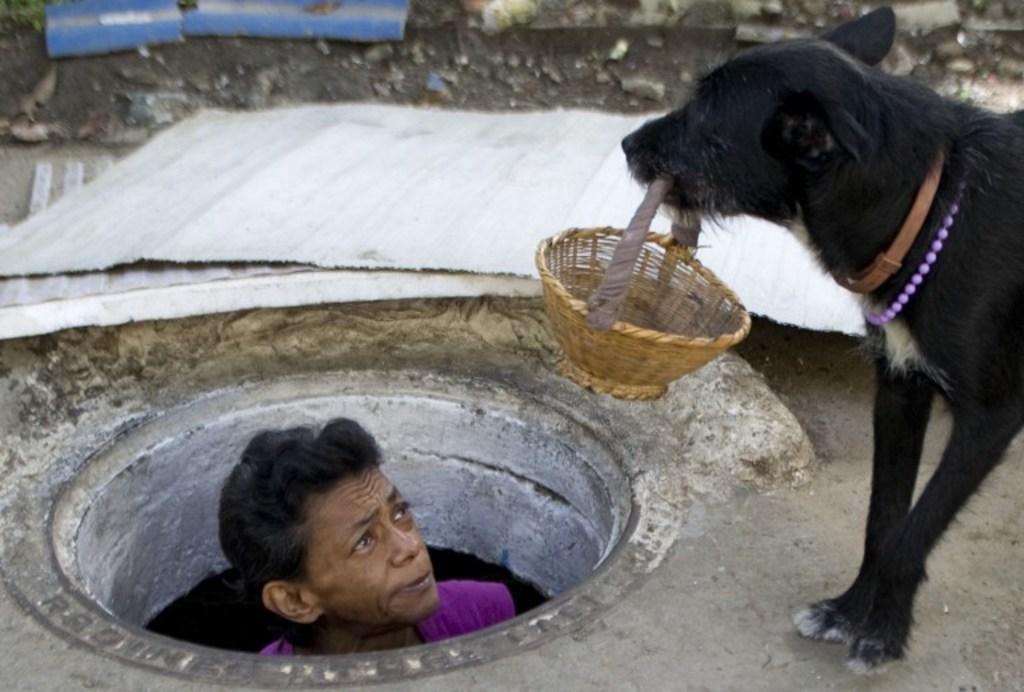Could you give a brief overview of what you see in this image? In this image I can see a dog is holding a basket in mouth, person in a pipe, metal rods and stones. This image is taken may be during a day. 